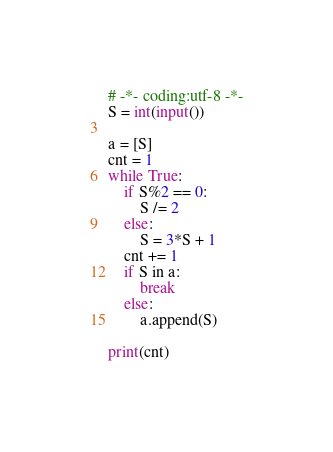<code> <loc_0><loc_0><loc_500><loc_500><_Python_># -*- coding:utf-8 -*-
S = int(input())

a = [S]
cnt = 1
while True:
    if S%2 == 0:
        S /= 2
    else:
        S = 3*S + 1
    cnt += 1
    if S in a:
        break
    else:
        a.append(S)

print(cnt)</code> 